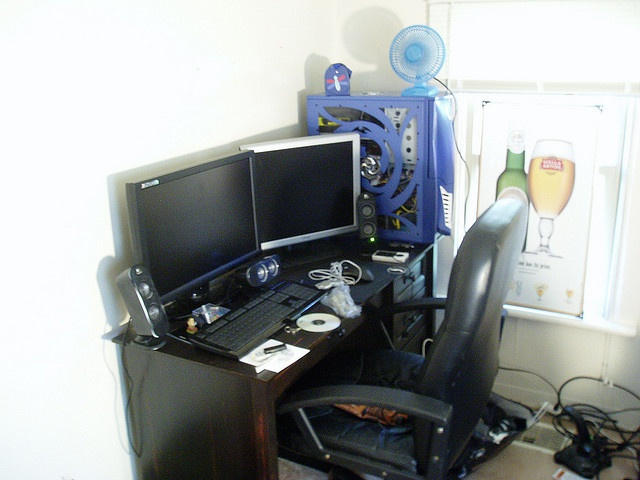Describe the objects in this image and their specific colors. I can see chair in white, black, gray, navy, and darkgray tones, tv in white, black, gray, navy, and darkgray tones, tv in white, black, lightgray, navy, and darkgray tones, keyboard in white, black, gray, navy, and blue tones, and bottle in white, lightgreen, darkgray, and olive tones in this image. 